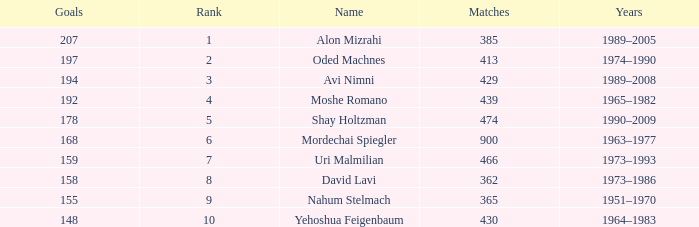What is the Rank of the player with 158 Goals in more than 362 Matches? 0.0. 